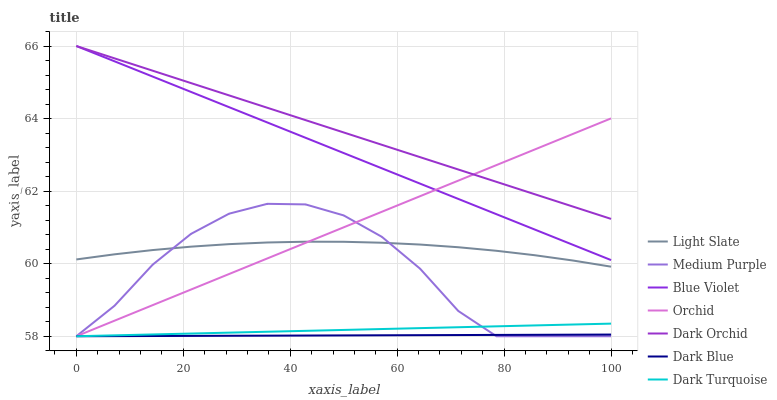Does Dark Blue have the minimum area under the curve?
Answer yes or no. Yes. Does Dark Orchid have the maximum area under the curve?
Answer yes or no. Yes. Does Dark Turquoise have the minimum area under the curve?
Answer yes or no. No. Does Dark Turquoise have the maximum area under the curve?
Answer yes or no. No. Is Orchid the smoothest?
Answer yes or no. Yes. Is Medium Purple the roughest?
Answer yes or no. Yes. Is Dark Turquoise the smoothest?
Answer yes or no. No. Is Dark Turquoise the roughest?
Answer yes or no. No. Does Dark Turquoise have the lowest value?
Answer yes or no. Yes. Does Dark Orchid have the lowest value?
Answer yes or no. No. Does Blue Violet have the highest value?
Answer yes or no. Yes. Does Dark Turquoise have the highest value?
Answer yes or no. No. Is Dark Turquoise less than Light Slate?
Answer yes or no. Yes. Is Blue Violet greater than Light Slate?
Answer yes or no. Yes. Does Medium Purple intersect Light Slate?
Answer yes or no. Yes. Is Medium Purple less than Light Slate?
Answer yes or no. No. Is Medium Purple greater than Light Slate?
Answer yes or no. No. Does Dark Turquoise intersect Light Slate?
Answer yes or no. No. 